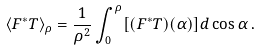<formula> <loc_0><loc_0><loc_500><loc_500>\langle F ^ { * } T \rangle _ { \rho } = \frac { 1 } { \rho ^ { 2 } } \int _ { 0 } ^ { \rho } [ ( F ^ { * } T ) ( \alpha ) ] d \cos \alpha \, .</formula> 